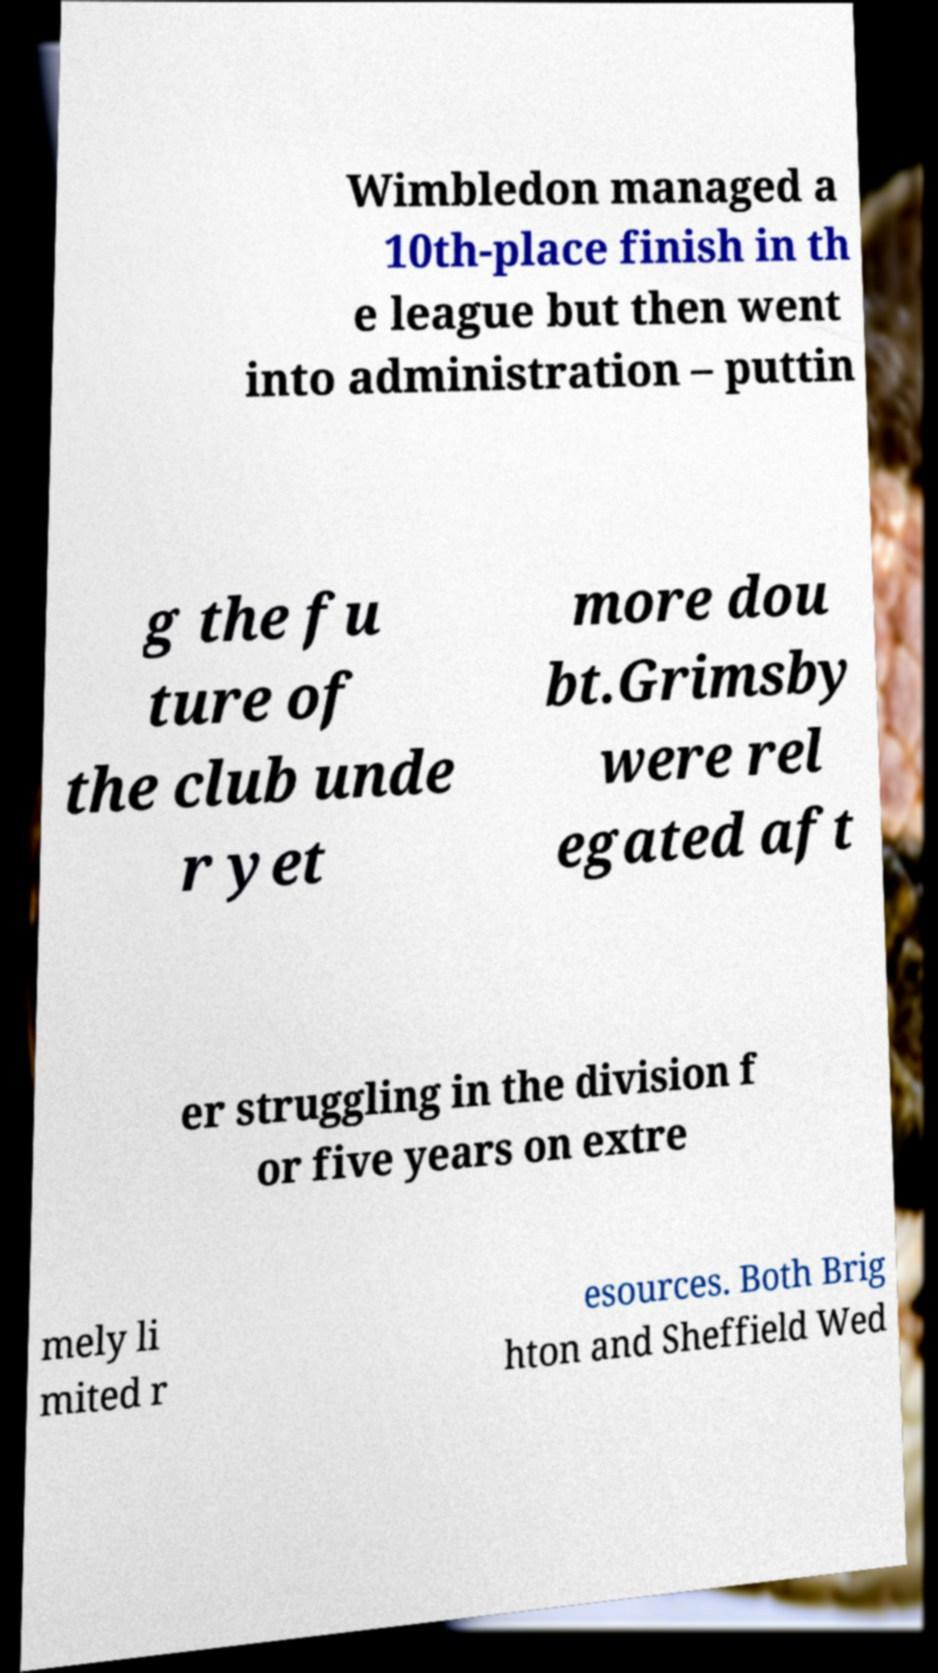Could you extract and type out the text from this image? Wimbledon managed a 10th-place finish in th e league but then went into administration – puttin g the fu ture of the club unde r yet more dou bt.Grimsby were rel egated aft er struggling in the division f or five years on extre mely li mited r esources. Both Brig hton and Sheffield Wed 